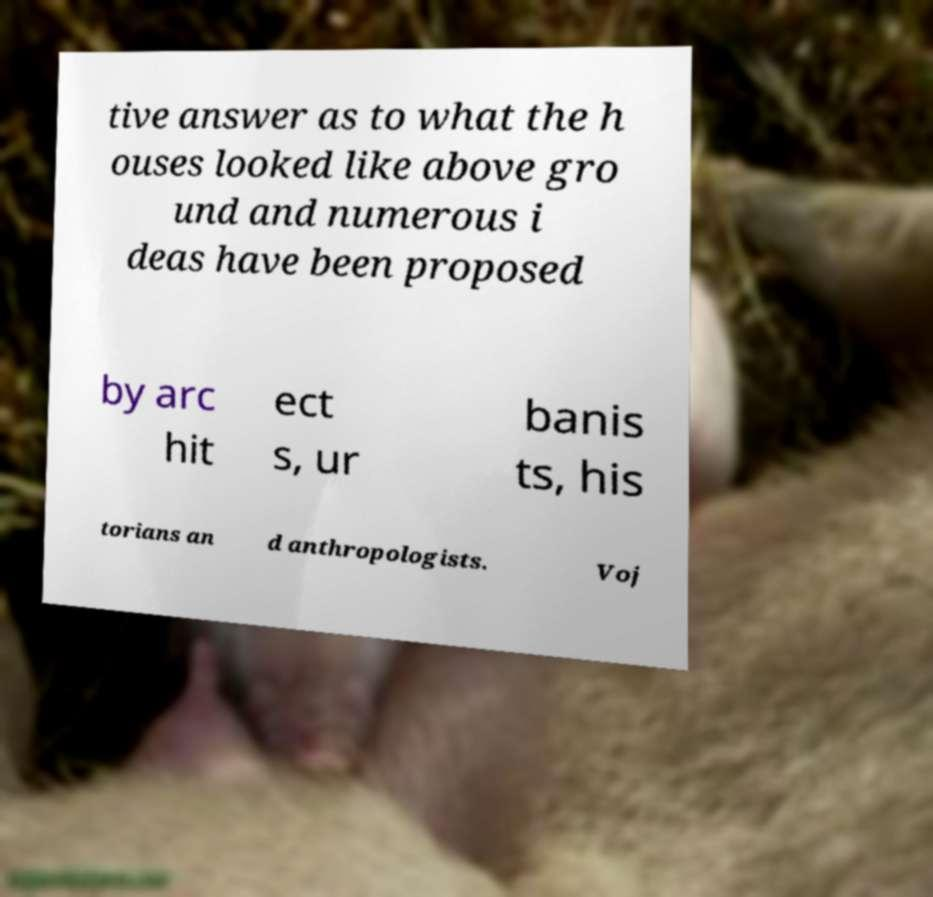Please read and relay the text visible in this image. What does it say? tive answer as to what the h ouses looked like above gro und and numerous i deas have been proposed by arc hit ect s, ur banis ts, his torians an d anthropologists. Voj 